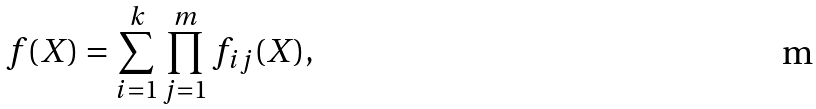<formula> <loc_0><loc_0><loc_500><loc_500>f ( X ) = \sum _ { i = 1 } ^ { k } \prod _ { j = 1 } ^ { m } f _ { i j } ( X ) ,</formula> 